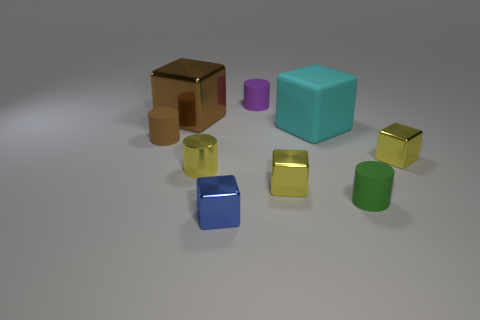Subtract all cyan blocks. How many blocks are left? 4 Subtract all brown metal blocks. How many blocks are left? 4 Subtract all gray cubes. Subtract all gray cylinders. How many cubes are left? 5 Add 1 tiny rubber cylinders. How many objects exist? 10 Subtract all blocks. How many objects are left? 4 Add 6 big cubes. How many big cubes exist? 8 Subtract 1 blue blocks. How many objects are left? 8 Subtract all things. Subtract all gray cylinders. How many objects are left? 0 Add 7 tiny cubes. How many tiny cubes are left? 10 